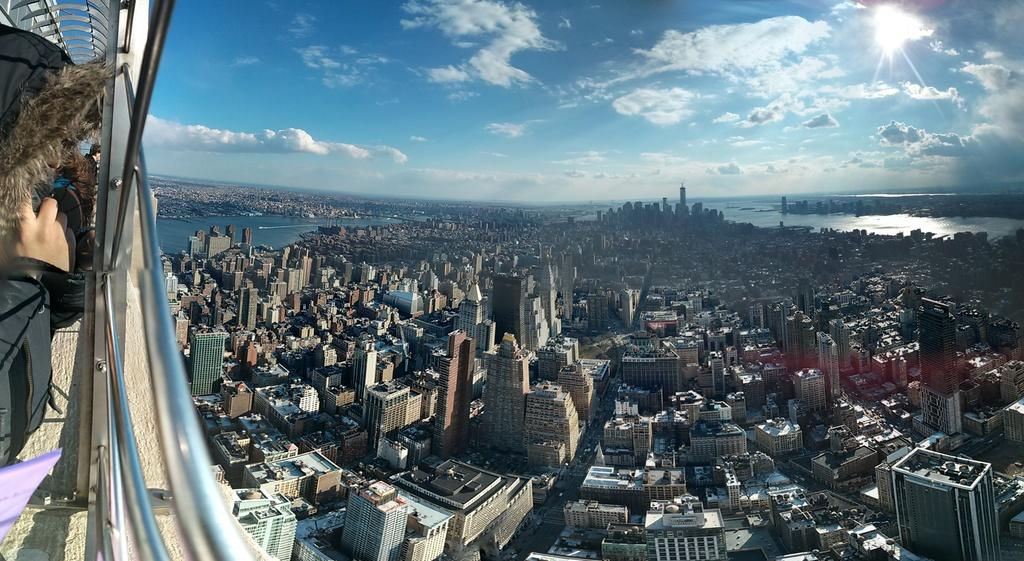What type of structures can be seen in the image? There are buildings in the image. What natural element is visible in the image? Water is visible in the image. What part of the image might be used for support or safety? There is railing in the image. What is visible in the sky in the image? The sky is visible in the image, and clouds are present. Can you tell me what time it is in the image? There is no clock or any indication of time in the image, so it is not possible to determine the hour. Is there a monkey visible in the image? No, there is no monkey present in the image. 